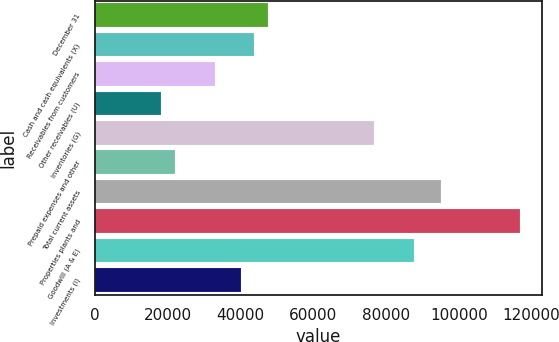Convert chart to OTSL. <chart><loc_0><loc_0><loc_500><loc_500><bar_chart><fcel>December 31<fcel>Cash and cash equivalents (X)<fcel>Receivables from customers<fcel>Other receivables (U)<fcel>Inventories (G)<fcel>Prepaid expenses and other<fcel>Total current assets<fcel>Properties plants and<fcel>Goodwill (A & E)<fcel>Investments (I)<nl><fcel>47485.5<fcel>43833<fcel>32875.5<fcel>18265.5<fcel>76705.5<fcel>21918<fcel>94968<fcel>116883<fcel>87663<fcel>40180.5<nl></chart> 